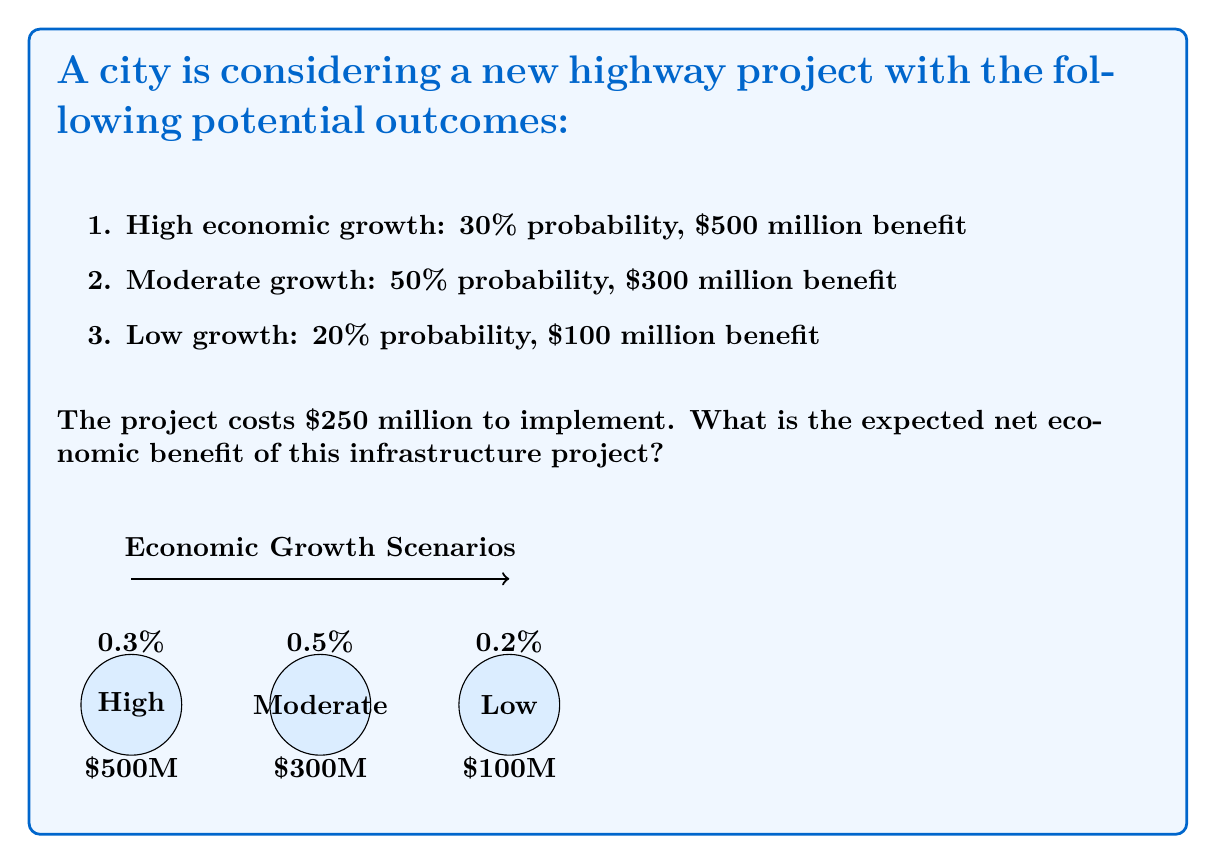Can you solve this math problem? To solve this problem, we need to:
1. Calculate the expected benefit
2. Subtract the implementation cost
3. Determine the net benefit

Step 1: Calculate the expected benefit
The expected benefit is the sum of each possible outcome multiplied by its probability:

$$ E(\text{Benefit}) = \sum_{i=1}^n P_i \cdot V_i $$

Where $P_i$ is the probability of each outcome and $V_i$ is the value of each outcome.

$$ E(\text{Benefit}) = (0.30 \cdot \$500M) + (0.50 \cdot \$300M) + (0.20 \cdot \$100M) $$
$$ = \$150M + \$150M + \$20M = \$320M $$

Step 2: Subtract the implementation cost
The net benefit is the expected benefit minus the cost:

$$ \text{Net Benefit} = E(\text{Benefit}) - \text{Cost} $$
$$ = \$320M - \$250M = \$70M $$

Step 3: Determine the net benefit
The expected net economic benefit is $70 million.
Answer: $70 million 